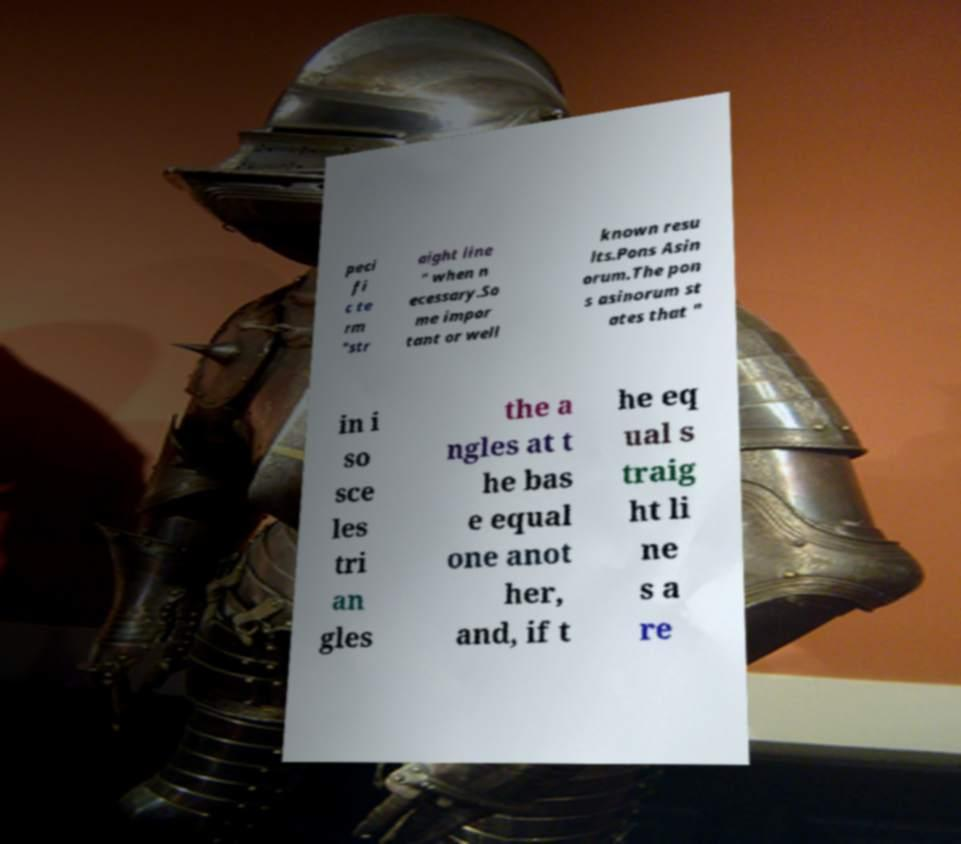Please read and relay the text visible in this image. What does it say? peci fi c te rm "str aight line " when n ecessary.So me impor tant or well known resu lts.Pons Asin orum.The pon s asinorum st ates that " in i so sce les tri an gles the a ngles at t he bas e equal one anot her, and, if t he eq ual s traig ht li ne s a re 